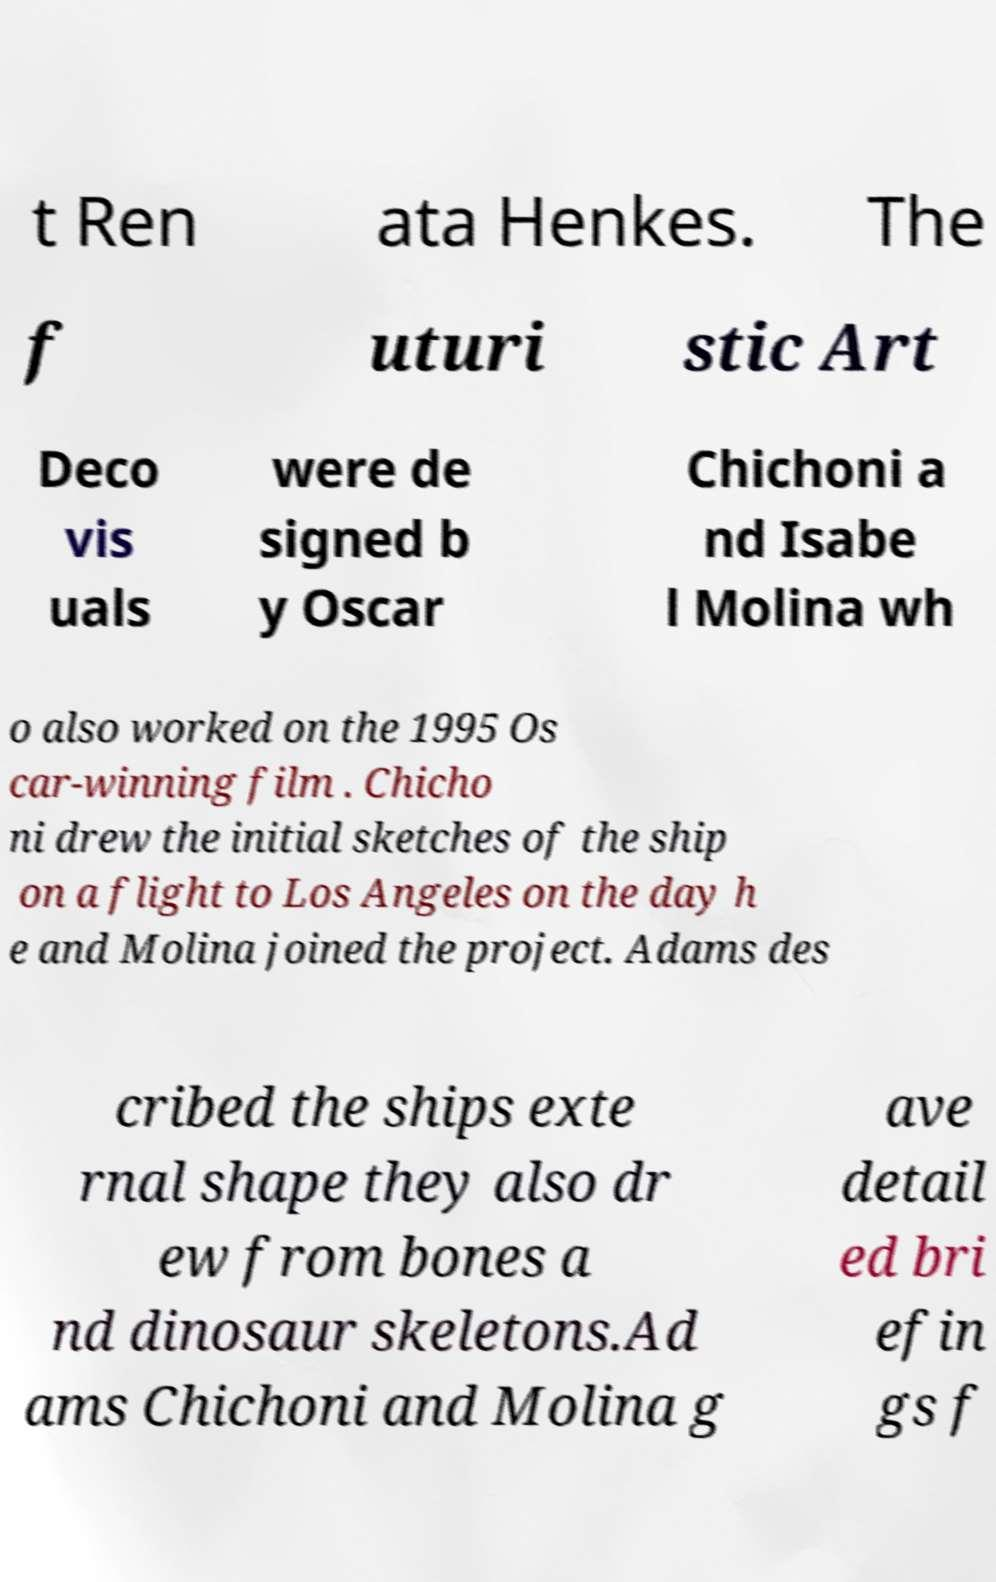What messages or text are displayed in this image? I need them in a readable, typed format. t Ren ata Henkes. The f uturi stic Art Deco vis uals were de signed b y Oscar Chichoni a nd Isabe l Molina wh o also worked on the 1995 Os car-winning film . Chicho ni drew the initial sketches of the ship on a flight to Los Angeles on the day h e and Molina joined the project. Adams des cribed the ships exte rnal shape they also dr ew from bones a nd dinosaur skeletons.Ad ams Chichoni and Molina g ave detail ed bri efin gs f 